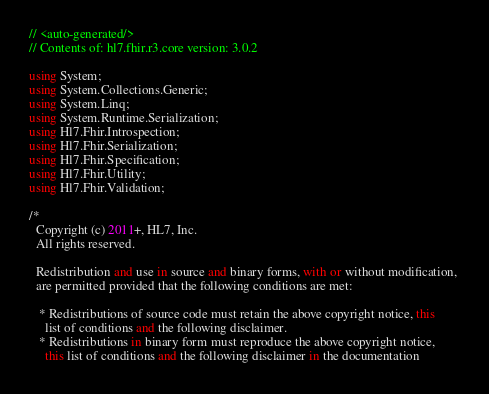<code> <loc_0><loc_0><loc_500><loc_500><_C#_>// <auto-generated/>
// Contents of: hl7.fhir.r3.core version: 3.0.2

using System;
using System.Collections.Generic;
using System.Linq;
using System.Runtime.Serialization;
using Hl7.Fhir.Introspection;
using Hl7.Fhir.Serialization;
using Hl7.Fhir.Specification;
using Hl7.Fhir.Utility;
using Hl7.Fhir.Validation;

/*
  Copyright (c) 2011+, HL7, Inc.
  All rights reserved.
  
  Redistribution and use in source and binary forms, with or without modification, 
  are permitted provided that the following conditions are met:
  
   * Redistributions of source code must retain the above copyright notice, this 
     list of conditions and the following disclaimer.
   * Redistributions in binary form must reproduce the above copyright notice, 
     this list of conditions and the following disclaimer in the documentation </code> 